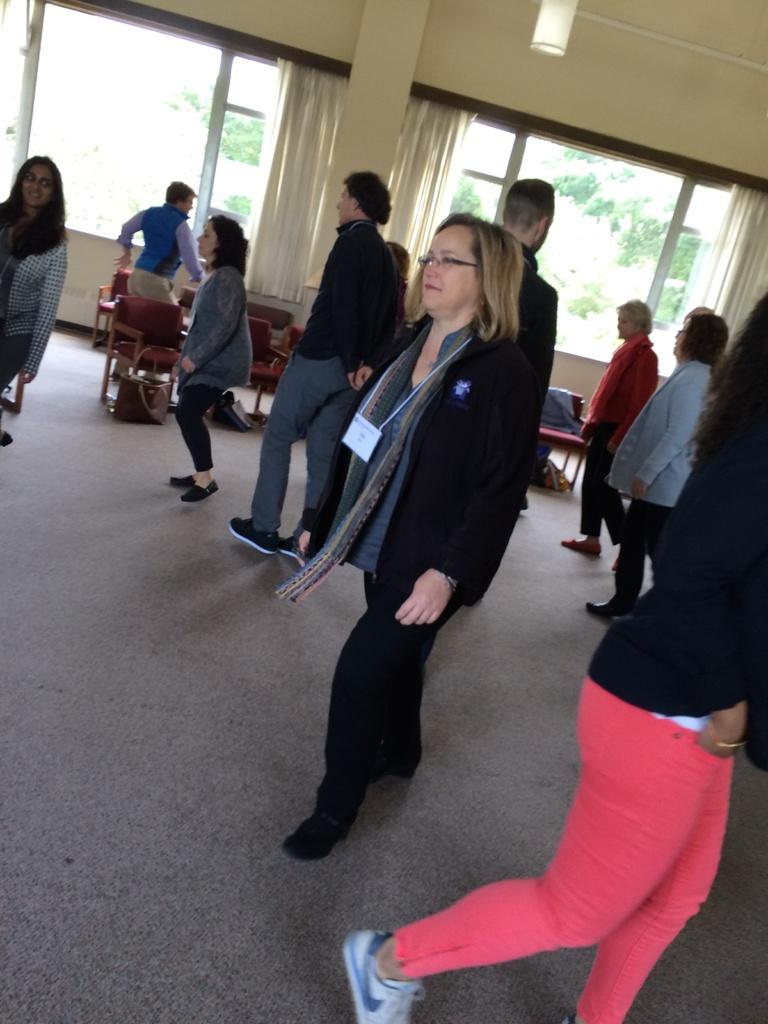What are the people in the image doing? The people in the image are walking. What type of furniture can be seen in the image? There are chairs in the image. What can be found near the windows in the image? The windows in the image have curtains. What type of beef is being served in the image? There is no beef present in the image; it features people walking and chairs. How can you tell if the room is quiet in the image? The image does not provide any information about the noise level in the room. 